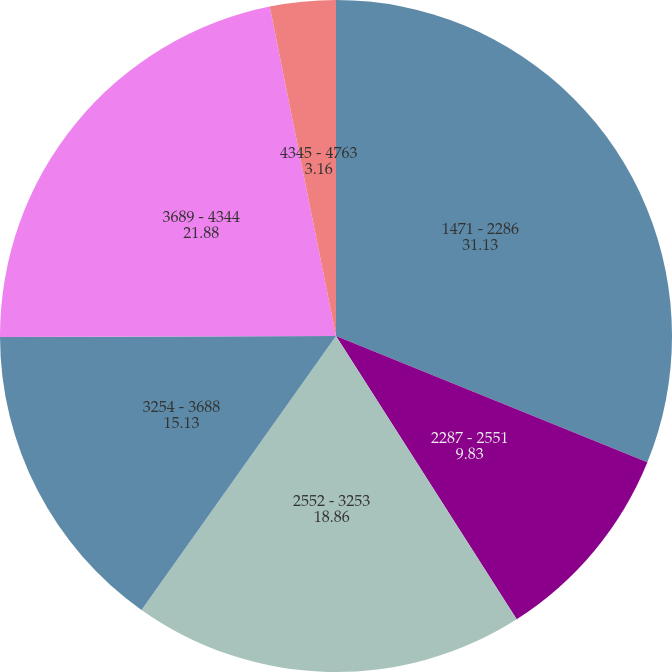<chart> <loc_0><loc_0><loc_500><loc_500><pie_chart><fcel>1471 - 2286<fcel>2287 - 2551<fcel>2552 - 3253<fcel>3254 - 3688<fcel>3689 - 4344<fcel>4345 - 4763<nl><fcel>31.13%<fcel>9.83%<fcel>18.86%<fcel>15.13%<fcel>21.88%<fcel>3.16%<nl></chart> 